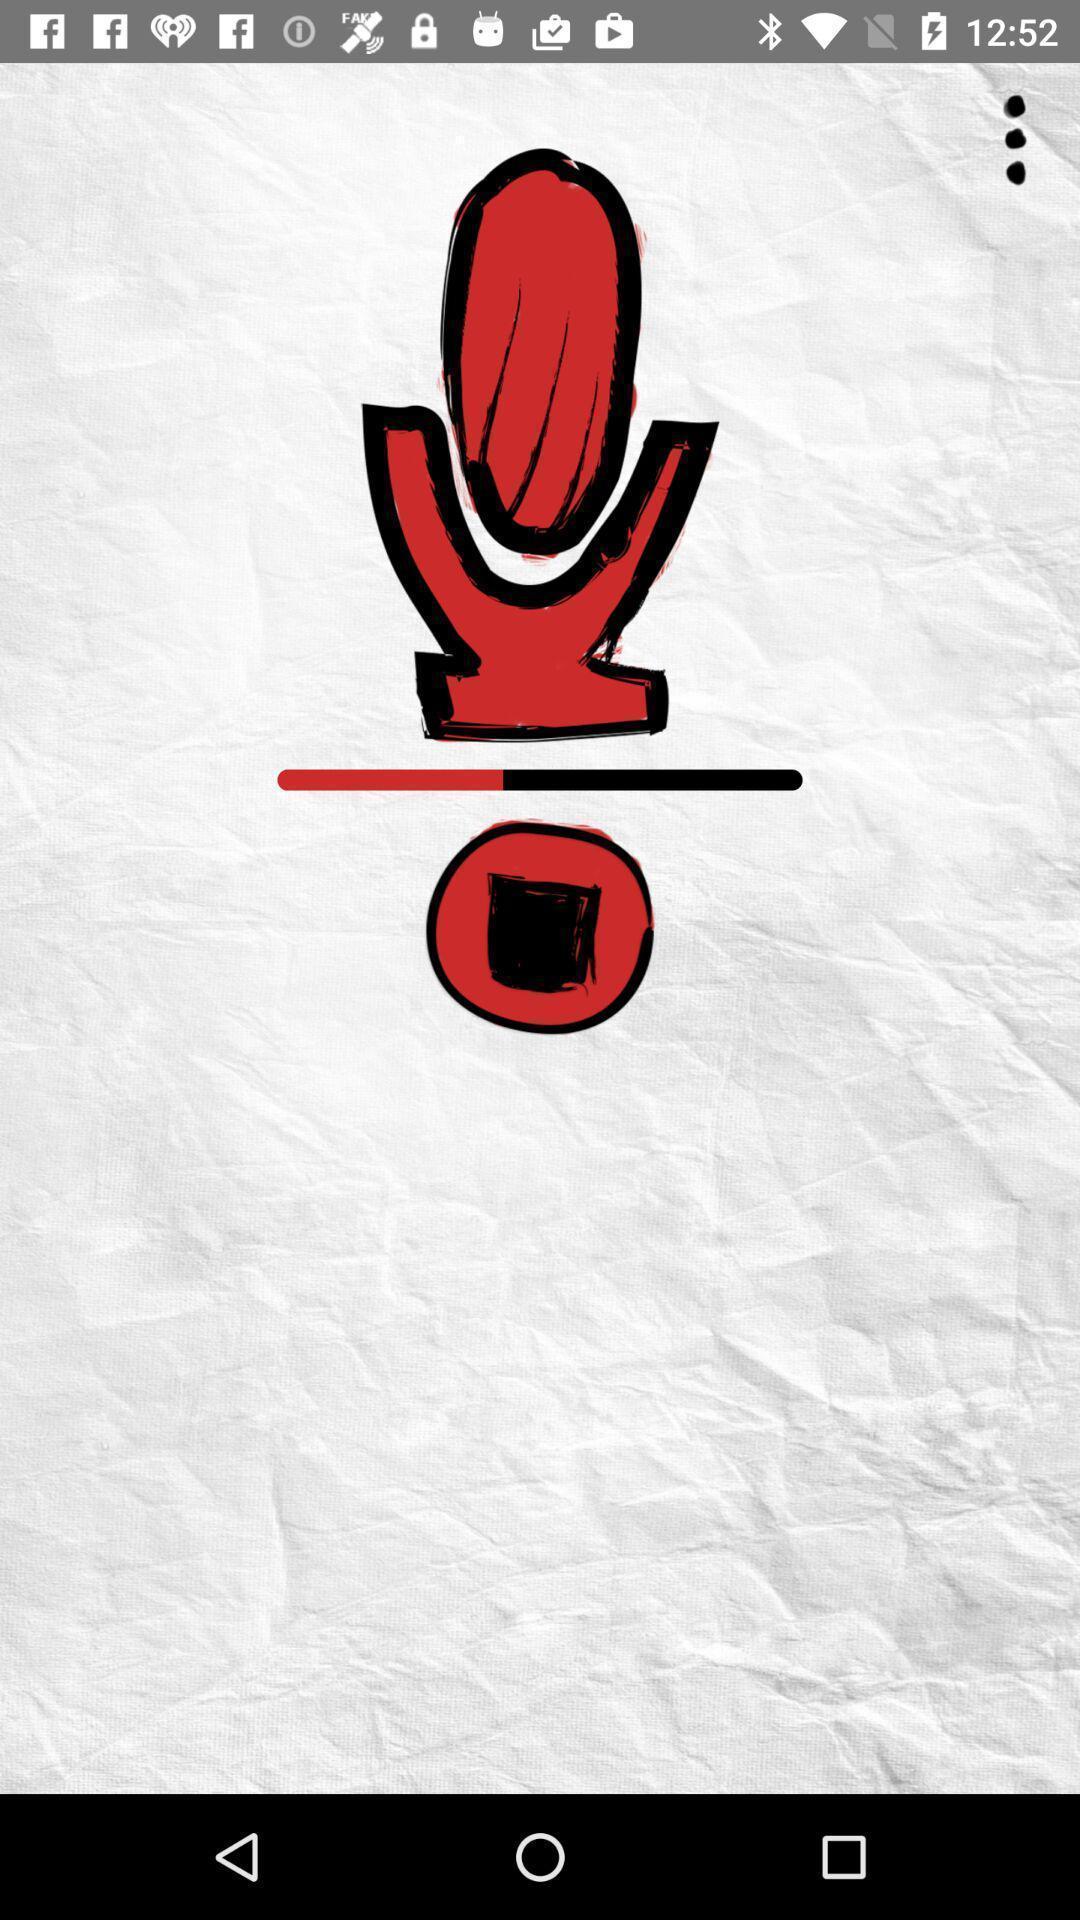Summarize the main components in this picture. Page displaying image of recorder in app. 